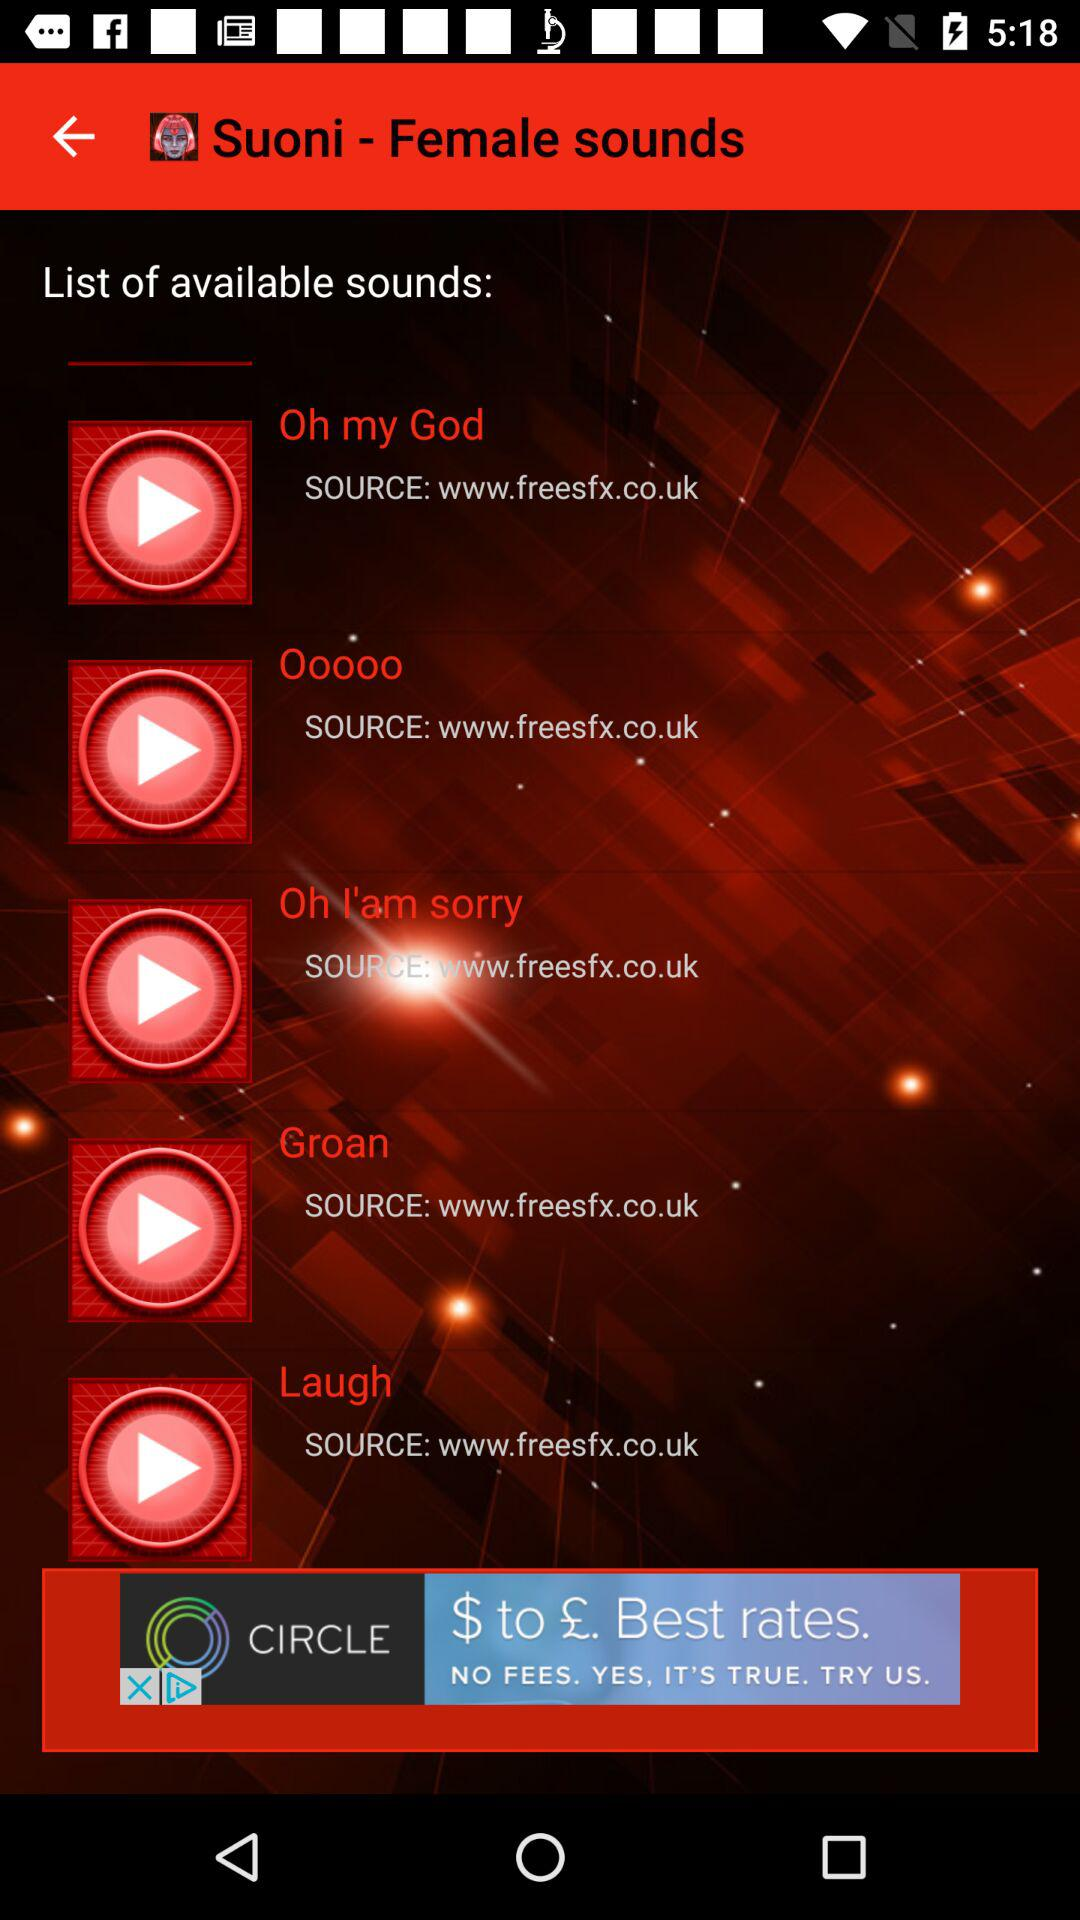What is the source of the sound "Laugh"? The source is "www.freesfx.co.uk". 